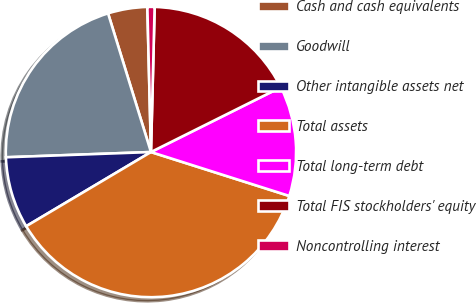<chart> <loc_0><loc_0><loc_500><loc_500><pie_chart><fcel>Cash and cash equivalents<fcel>Goodwill<fcel>Other intangible assets net<fcel>Total assets<fcel>Total long-term debt<fcel>Total FIS stockholders' equity<fcel>Noncontrolling interest<nl><fcel>4.38%<fcel>20.8%<fcel>7.96%<fcel>36.57%<fcel>12.26%<fcel>17.23%<fcel>0.8%<nl></chart> 